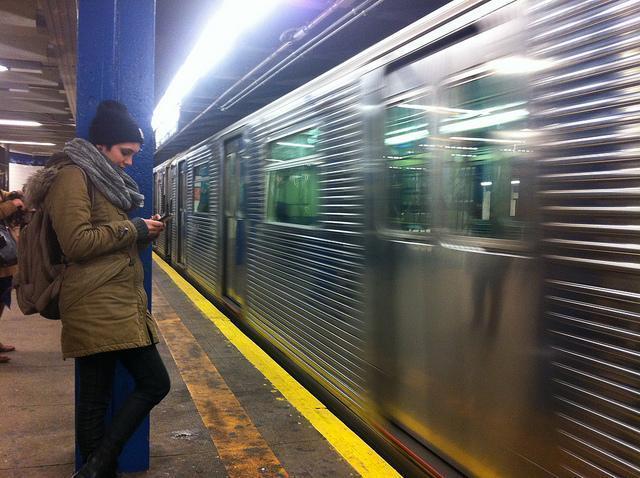What type of communication is she using?
From the following four choices, select the correct answer to address the question.
Options: Verbal, written, gestures, electronic. Electronic. 